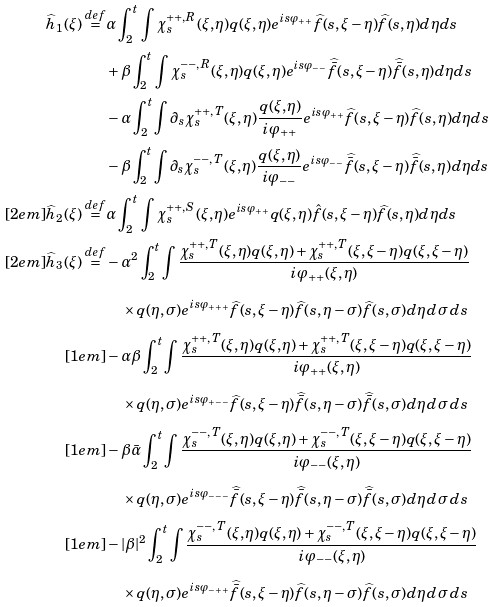<formula> <loc_0><loc_0><loc_500><loc_500>\widehat { h } _ { 1 } ( \xi ) \overset { d e f } { = } & \alpha \int _ { 2 } ^ { t } \, \int \chi _ { s } ^ { + + , R } ( \xi , \eta ) q ( \xi , \eta ) e ^ { i s \varphi _ { + + } } \widehat { f } ( s , \xi - \eta ) \widehat { f } ( s , \eta ) d \eta d s \\ & + \beta \int _ { 2 } ^ { t } \, \int \chi _ { s } ^ { - - , R } ( \xi , \eta ) q ( \xi , \eta ) e ^ { i s \varphi _ { - - } } \widehat { \bar { f } } ( s , \xi - \eta ) \widehat { \bar { f } } ( s , \eta ) d \eta d s \\ & - \alpha \int _ { 2 } ^ { t } \int \partial _ { s } \chi _ { s } ^ { + + , T } ( \xi , \eta ) \frac { q ( \xi , \eta ) } { i \varphi _ { + + } } e ^ { i s \varphi _ { + + } } \widehat { f } ( s , \xi - \eta ) \widehat { f } ( s , \eta ) d \eta d s \\ & - \beta \int _ { 2 } ^ { t } \int \partial _ { s } \chi _ { s } ^ { - - , T } ( \xi , \eta ) \frac { q ( \xi , \eta ) } { i \varphi _ { - - } } e ^ { i s \varphi _ { - - } } \widehat { \bar { f } } ( s , \xi - \eta ) \widehat { \bar { f } } ( s , \eta ) d \eta d s \\ [ 2 e m ] \widehat { h } _ { 2 } ( \xi ) \overset { d e f } { = } & \alpha \int _ { 2 } ^ { t } \, \int \chi _ { s } ^ { + + , S } ( \xi , \eta ) e ^ { i s \varphi _ { + + } } q ( \xi , \eta ) \hat { f } ( s , \xi - \eta ) \widehat { f } ( s , \eta ) d \eta d s \\ [ 2 e m ] \widehat { h } _ { 3 } ( \xi ) \overset { d e f } { = } & - \alpha ^ { 2 } \int _ { 2 } ^ { t } \int \frac { \chi _ { s } ^ { + + , T } ( \xi , \eta ) q ( \xi , \eta ) + \chi _ { s } ^ { + + , T } ( \xi , \xi - \eta ) q ( \xi , \xi - \eta ) } { i \varphi _ { + + } ( \xi , \eta ) } \\ & \quad \times q ( \eta , \sigma ) e ^ { i s \varphi _ { + + + } } \widehat { f } ( s , \xi - \eta ) \widehat { f } ( s , \eta - \sigma ) \widehat { f } ( s , \sigma ) d \eta \, d \sigma \, d s \\ [ 1 e m ] & - \alpha \beta \int _ { 2 } ^ { t } \int \frac { \chi _ { s } ^ { + + , T } ( \xi , \eta ) q ( \xi , \eta ) + \chi _ { s } ^ { + + , T } ( \xi , \xi - \eta ) q ( \xi , \xi - \eta ) } { i \varphi _ { + + } ( \xi , \eta ) } \\ & \quad \times q ( \eta , \sigma ) e ^ { i s \varphi _ { + - - } } \widehat { f } ( s , \xi - \eta ) \widehat { \bar { f } } ( s , \eta - \sigma ) \widehat { \bar { f } } ( s , \sigma ) d \eta \, d \sigma \, d s \\ [ 1 e m ] & - \beta \bar { \alpha } \int _ { 2 } ^ { t } \int \frac { \chi _ { s } ^ { - - , T } ( \xi , \eta ) q ( \xi , \eta ) + \chi _ { s } ^ { - - , T } ( \xi , \xi - \eta ) q ( \xi , \xi - \eta ) } { i \varphi _ { - - } ( \xi , \eta ) } \\ & \quad \times q ( \eta , \sigma ) e ^ { i s \varphi _ { - - - } } \widehat { \bar { f } } ( s , \xi - \eta ) \widehat { \bar { f } } ( s , \eta - \sigma ) \widehat { \bar { f } } ( s , \sigma ) d \eta \, d \sigma \, d s \\ [ 1 e m ] & - | \beta | ^ { 2 } \int _ { 2 } ^ { t } \int \frac { \chi _ { s } ^ { - - , T } ( \xi , \eta ) q ( \xi , \eta ) + \chi _ { s } ^ { - - , T } ( \xi , \xi - \eta ) q ( \xi , \xi - \eta ) } { i \varphi _ { - - } ( \xi , \eta ) } \\ & \quad \times q ( \eta , \sigma ) e ^ { i s \varphi _ { - + + } } \widehat { \bar { f } } ( s , \xi - \eta ) \widehat { f } ( s , \eta - \sigma ) \widehat { f } ( s , \sigma ) d \eta \, d \sigma \, d s \\</formula> 